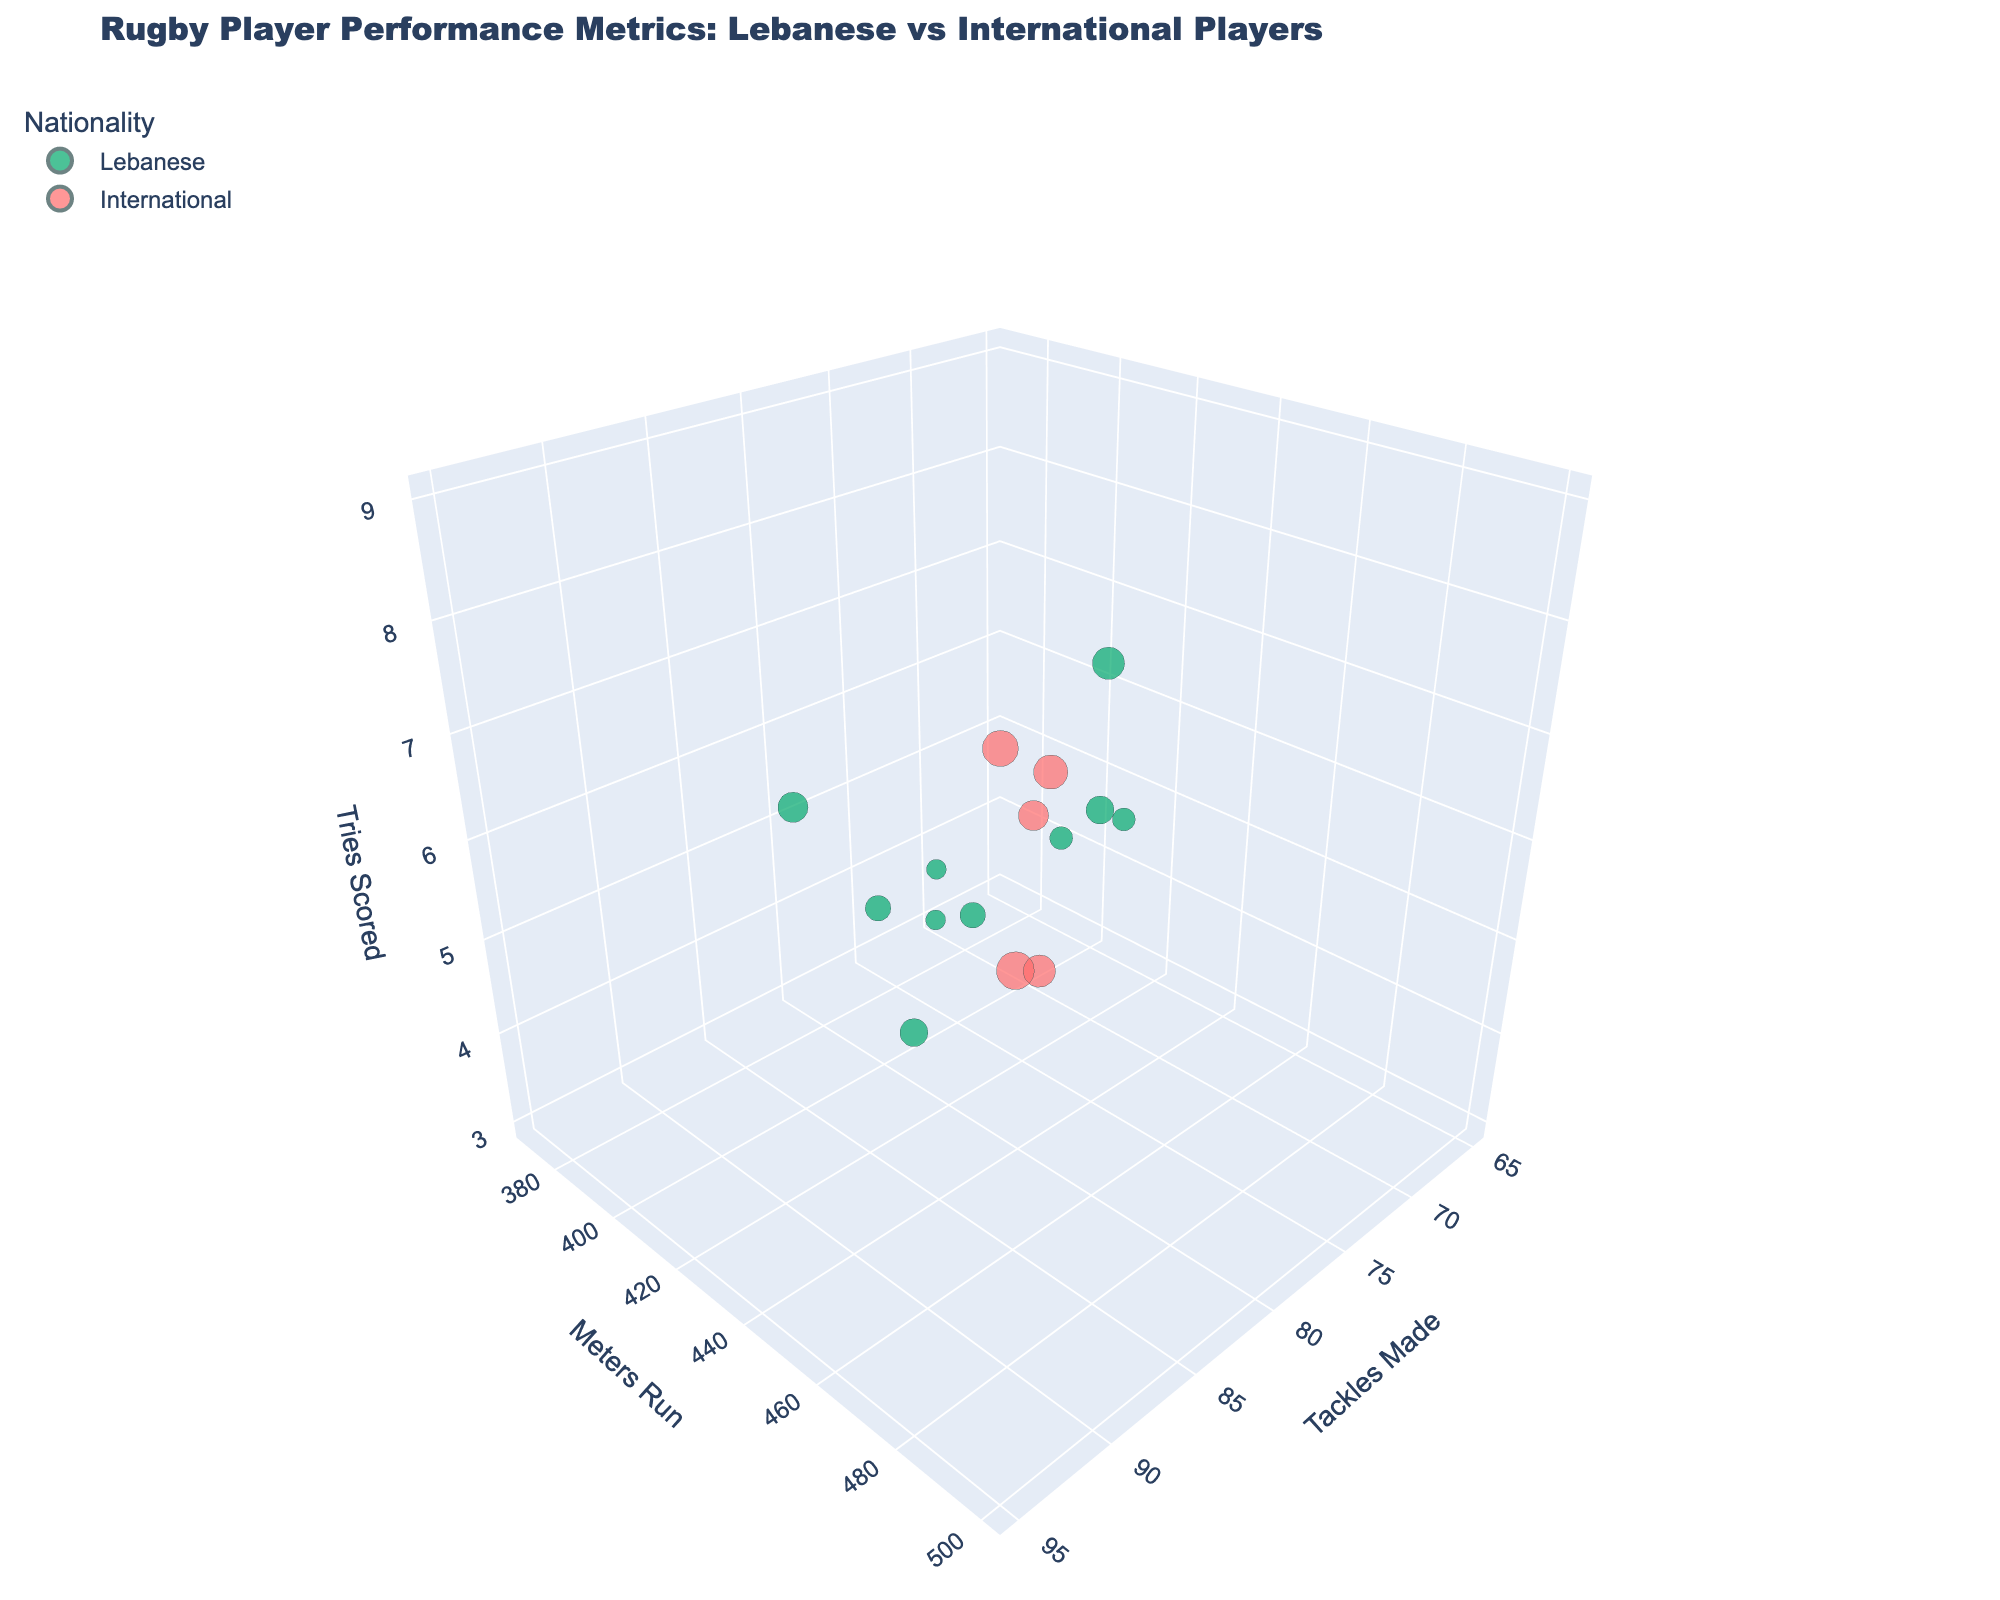What colors are used to differentiate Lebanese and International players? Lebanese players are colored green while International players are colored red. This is easy to identify from the clear color designation in the title and legend.
Answer: Green and Red How many Lebanese players have tackles made between 70 and 80? You look at the 'Tackles Made' axis and count the Lebanese players within the 70-80 range. From the bubble chart, we see multiple Lebanese bubbles within this interval.
Answer: 3 Who is the player with the highest number of tackles made? Look at the 'Tackles Made' axis and find the highest value. The bubble with the highest 'Tackles Made' is an International player named John Smith.
Answer: John Smith How does the number of meters run by Karim Aoun compare to Pierre Dupont? Locate bubbles for Karim Aoun and Pierre Dupont, check their height along the 'Meters Run' axis. Karim Aoun has run 380 meters, which is less than Pierre Dupont who has run 480 meters.
Answer: Karim Aoun < Pierre Dupont What is the average number of years of experience among Lebanese players? Sum the experience years for all Lebanese players (5+3+4+6+7+4+5+3+6+8) which equals 51, then divide by the number of Lebanese players (10). The average is 51/10.
Answer: 5.1 years Which nationality group generally has higher tries scored: Lebanese or International players? Compare the overall height on the 'Tries Scored' axis between the two groups. International players generally occupy higher positions on this axis.
Answer: International players What is the total number of International players represented in the chart? Count the number of bubbles colored red representing International players.
Answer: 5 Who has more experience, Ahmad Jamil or Takashi Yamamoto? Ahmad Jamil has 5 years of experience, while Takashi Yamamoto has 7 years. Comparing these values, Takashi Yamamoto has more experience.
Answer: Takashi Yamamoto Which Lebanese player has the highest number of meters run? Identify which green bubble is highest on the 'Meters Run' axis. Ziad Tannous, with 460 meters, is the highest among Lebanese players.
Answer: Ziad Tannous Are there any International players with more than 480 meters run? Check the red bubbles on the 'Meters Run' axis to see if any exceed 480 meters. John Smith and David Johnson both exceed this value.
Answer: Yes 